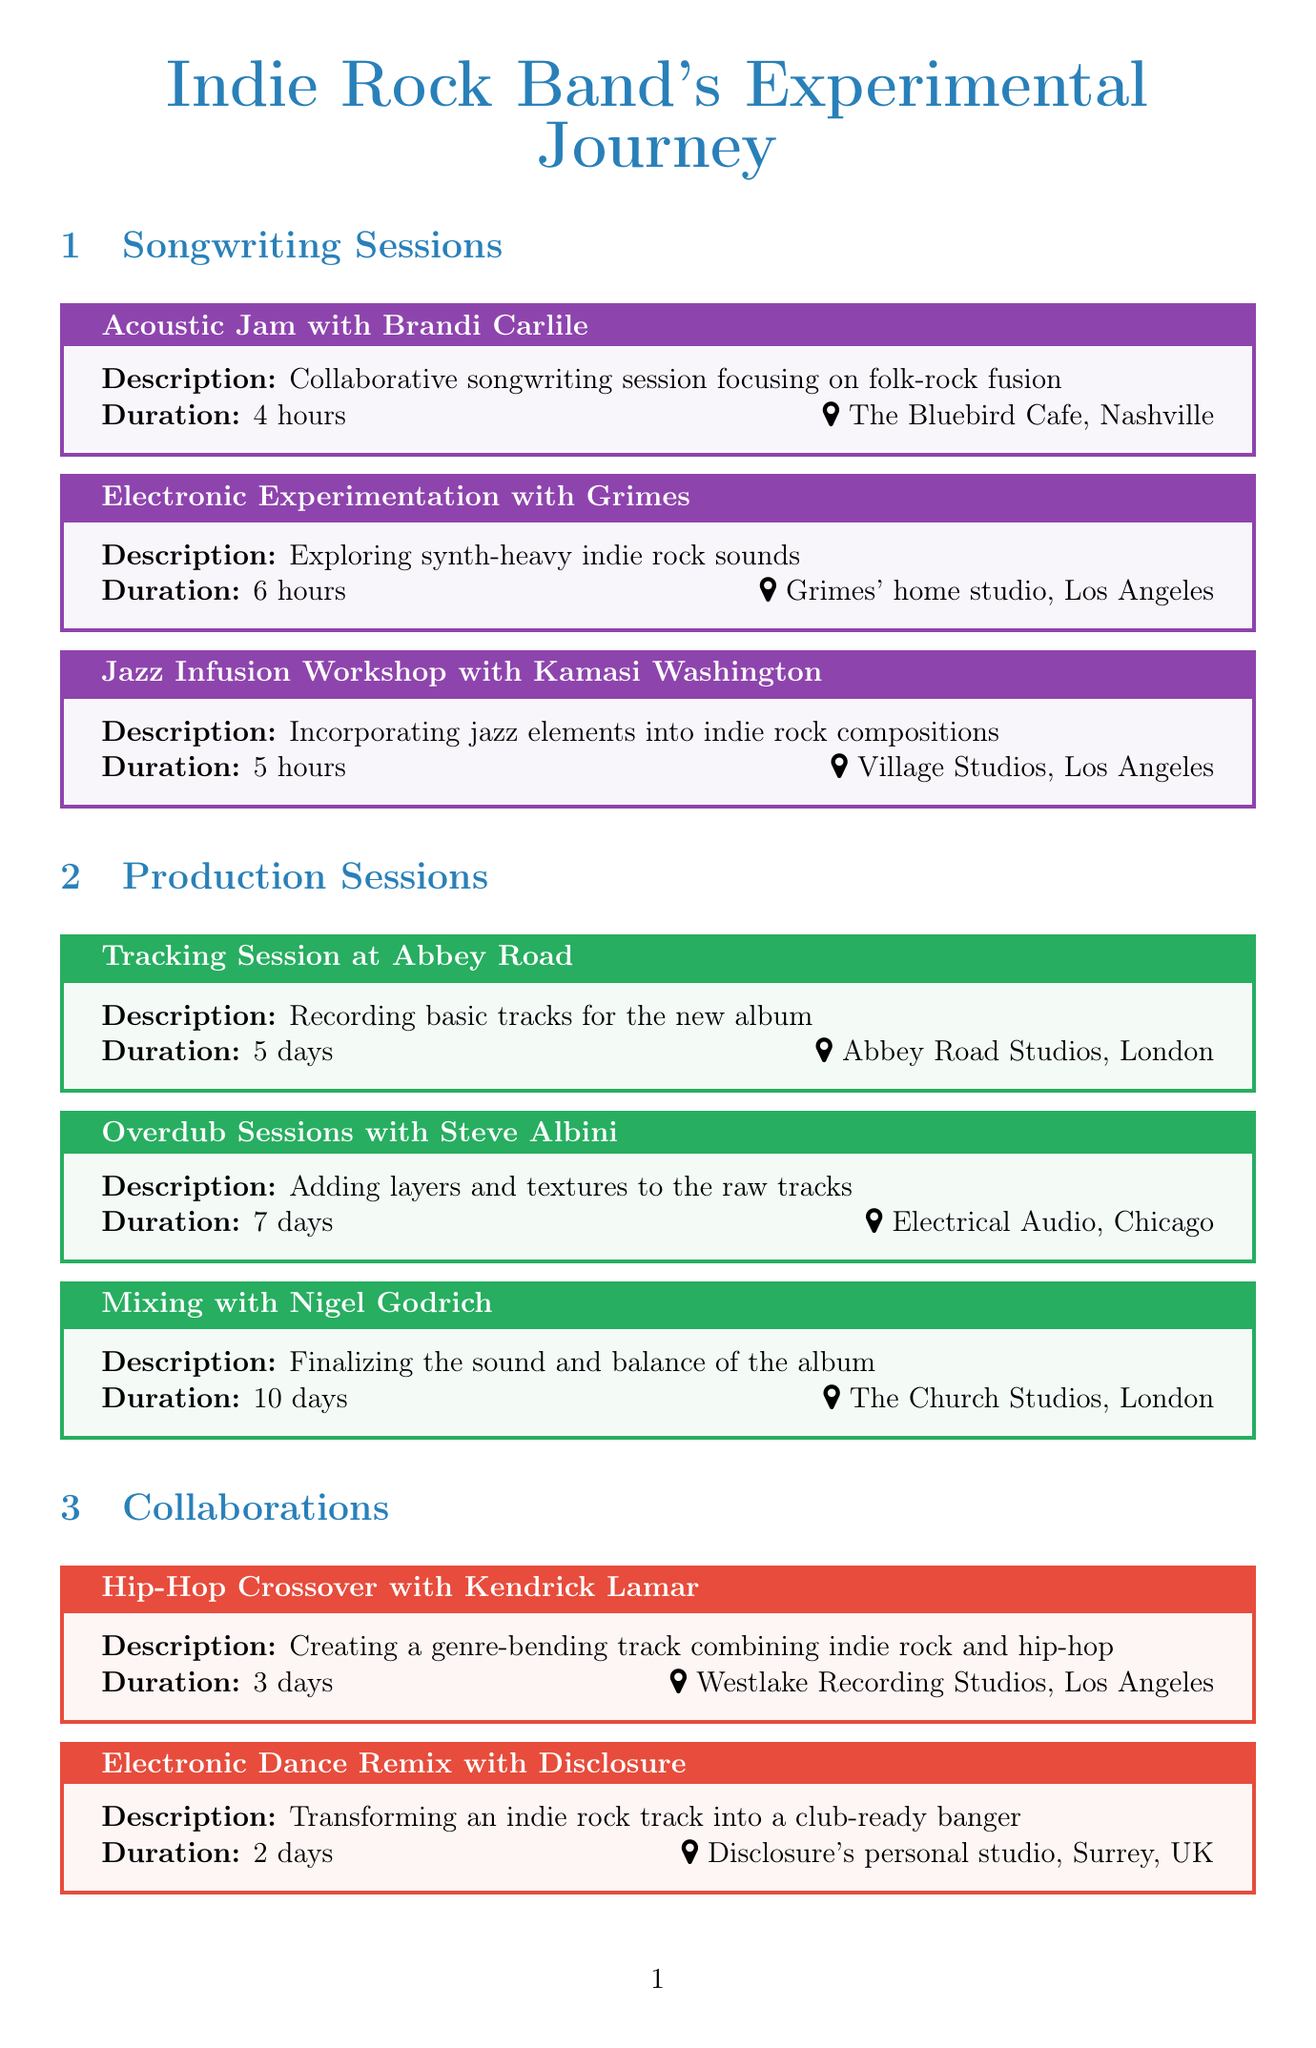what is the location of the Acoustic Jam session? The location is specified in the document as The Bluebird Cafe, Nashville.
Answer: The Bluebird Cafe, Nashville how long is the Mixing session with Nigel Godrich? The duration of the Mixing session is detailed in the document as 10 days.
Answer: 10 days who is collaborating for the Electronic Dance Remix? The document states that the collaboration is with Disclosure.
Answer: Disclosure what type of music elements are explored in the Jazz Infusion Workshop? The document indicates that jazz elements are incorporated into the compositions.
Answer: jazz elements what are the two main types of sessions included in the document? The document categorizes the sessions into songwriting and production sessions.
Answer: songwriting and production sessions how many days are allocated for the Band Rehearsals? The duration for Band Rehearsals is mentioned as 2 weeks.
Answer: 2 weeks which production session takes the longest time? The document shows that Mixing with Nigel Godrich lasts the longest at 10 days.
Answer: Mixing with Nigel Godrich which artist is involved in the Hip-Hop Crossover collaboration? The document specifies Kendrick Lamar as the artist for the Hip-Hop Crossover.
Answer: Kendrick Lamar what is the purpose of the Demo Recording session? The document describes it as laying down rough versions of new songs.
Answer: laying down rough versions of new songs 